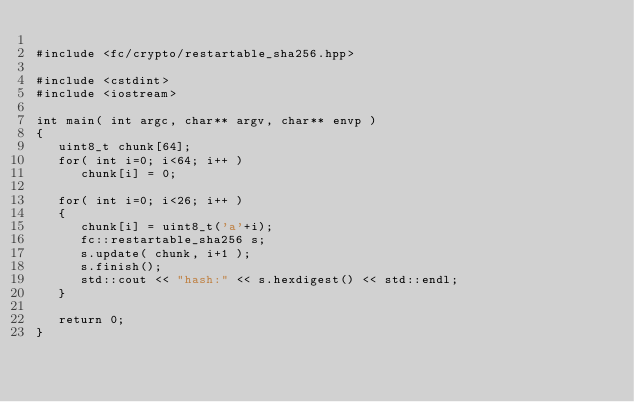<code> <loc_0><loc_0><loc_500><loc_500><_C++_>
#include <fc/crypto/restartable_sha256.hpp>

#include <cstdint>
#include <iostream>

int main( int argc, char** argv, char** envp )
{
   uint8_t chunk[64];
   for( int i=0; i<64; i++ )
      chunk[i] = 0;

   for( int i=0; i<26; i++ )
   {
      chunk[i] = uint8_t('a'+i);
      fc::restartable_sha256 s;
      s.update( chunk, i+1 );
      s.finish();
      std::cout << "hash:" << s.hexdigest() << std::endl;
   }

   return 0;
}
</code> 